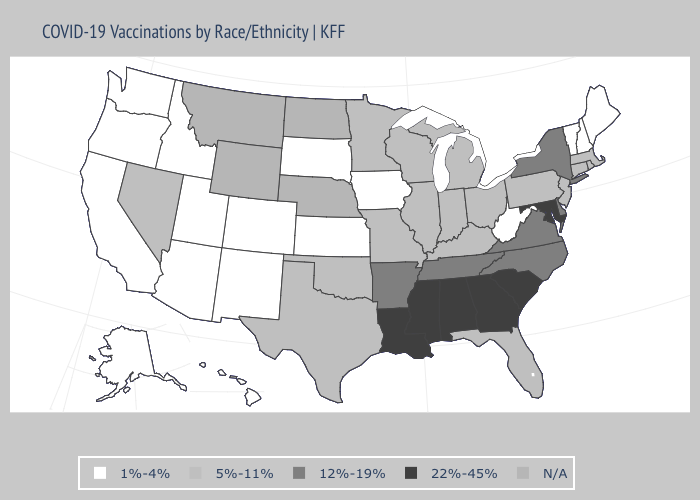What is the value of Pennsylvania?
Answer briefly. 5%-11%. What is the highest value in the USA?
Write a very short answer. 22%-45%. Which states have the lowest value in the South?
Be succinct. West Virginia. Name the states that have a value in the range 22%-45%?
Quick response, please. Alabama, Georgia, Louisiana, Maryland, Mississippi, South Carolina. Name the states that have a value in the range 22%-45%?
Short answer required. Alabama, Georgia, Louisiana, Maryland, Mississippi, South Carolina. What is the value of New Mexico?
Answer briefly. 1%-4%. Which states have the highest value in the USA?
Answer briefly. Alabama, Georgia, Louisiana, Maryland, Mississippi, South Carolina. What is the highest value in the Northeast ?
Be succinct. 12%-19%. What is the value of North Dakota?
Keep it brief. N/A. What is the value of Oregon?
Write a very short answer. 1%-4%. Name the states that have a value in the range 22%-45%?
Keep it brief. Alabama, Georgia, Louisiana, Maryland, Mississippi, South Carolina. Which states have the lowest value in the USA?
Answer briefly. Alaska, Arizona, California, Colorado, Hawaii, Idaho, Iowa, Kansas, Maine, New Hampshire, New Mexico, Oregon, South Dakota, Utah, Vermont, Washington, West Virginia. 